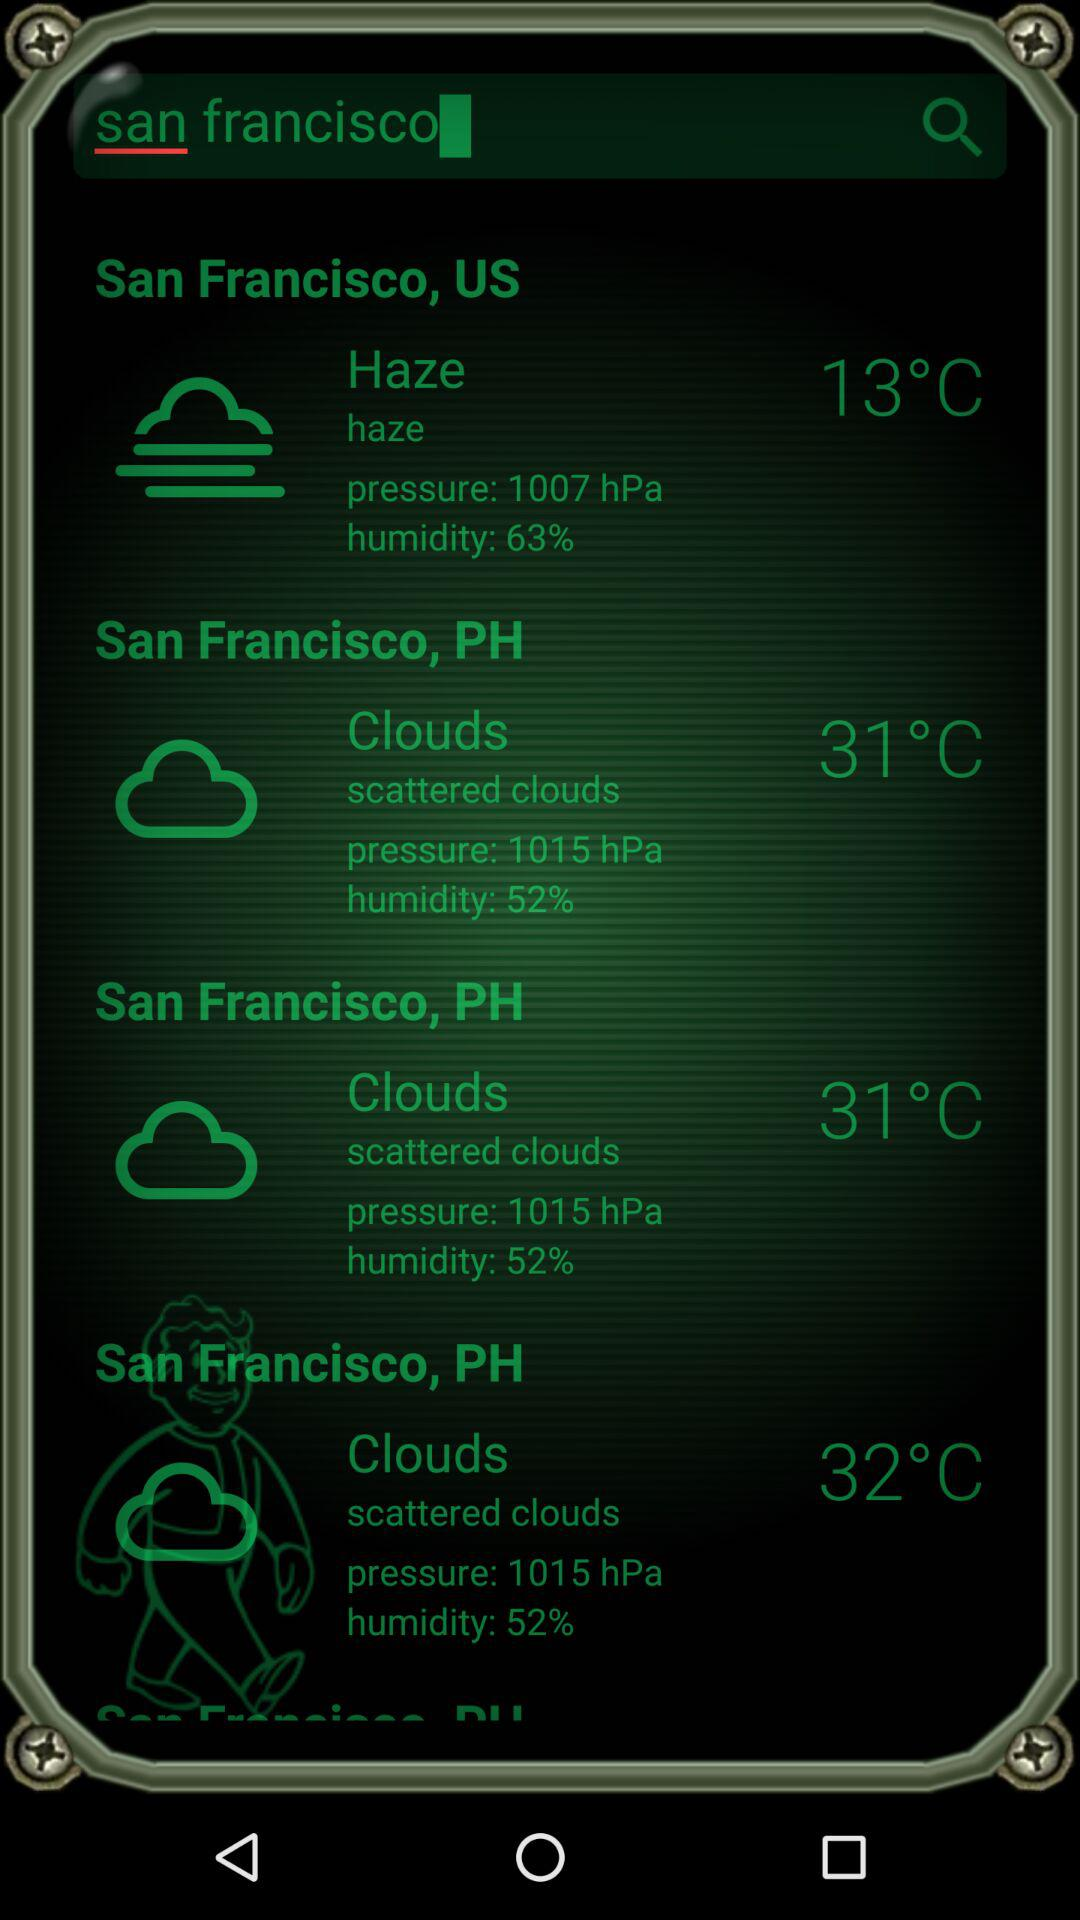What is the weather forecast for the cloud option whose temperature is 32 degrees Celsius?
When the provided information is insufficient, respond with <no answer>. <no answer> 